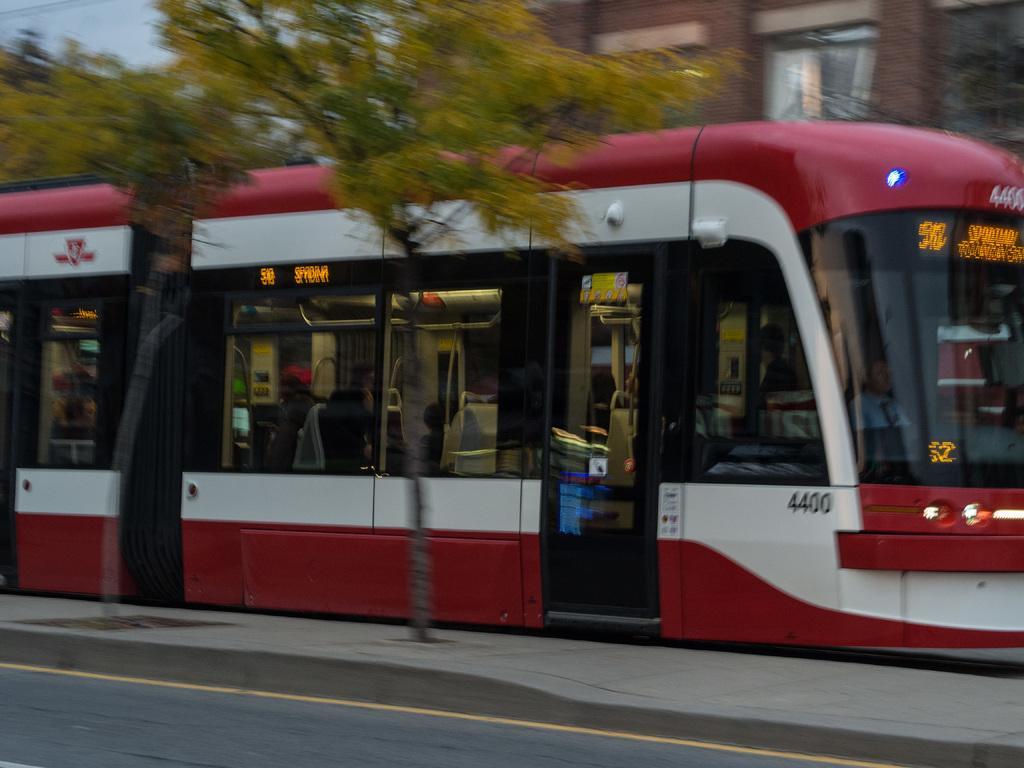How would you summarize this image in a sentence or two? Here there are trees and few persons in the bus are riding on a road. In the background there is a building,window,trees and sky. 